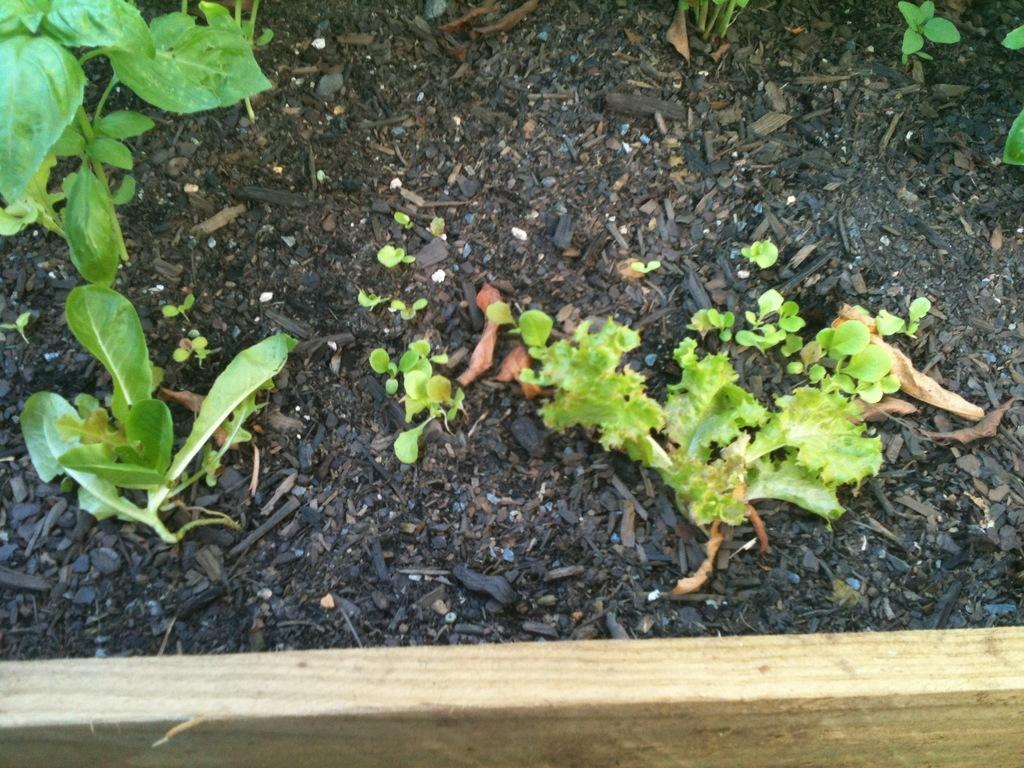Describe this image in one or two sentences. In this image there is a wooden frame, behind the wooden frame there is soil, in that soil there are plants. 